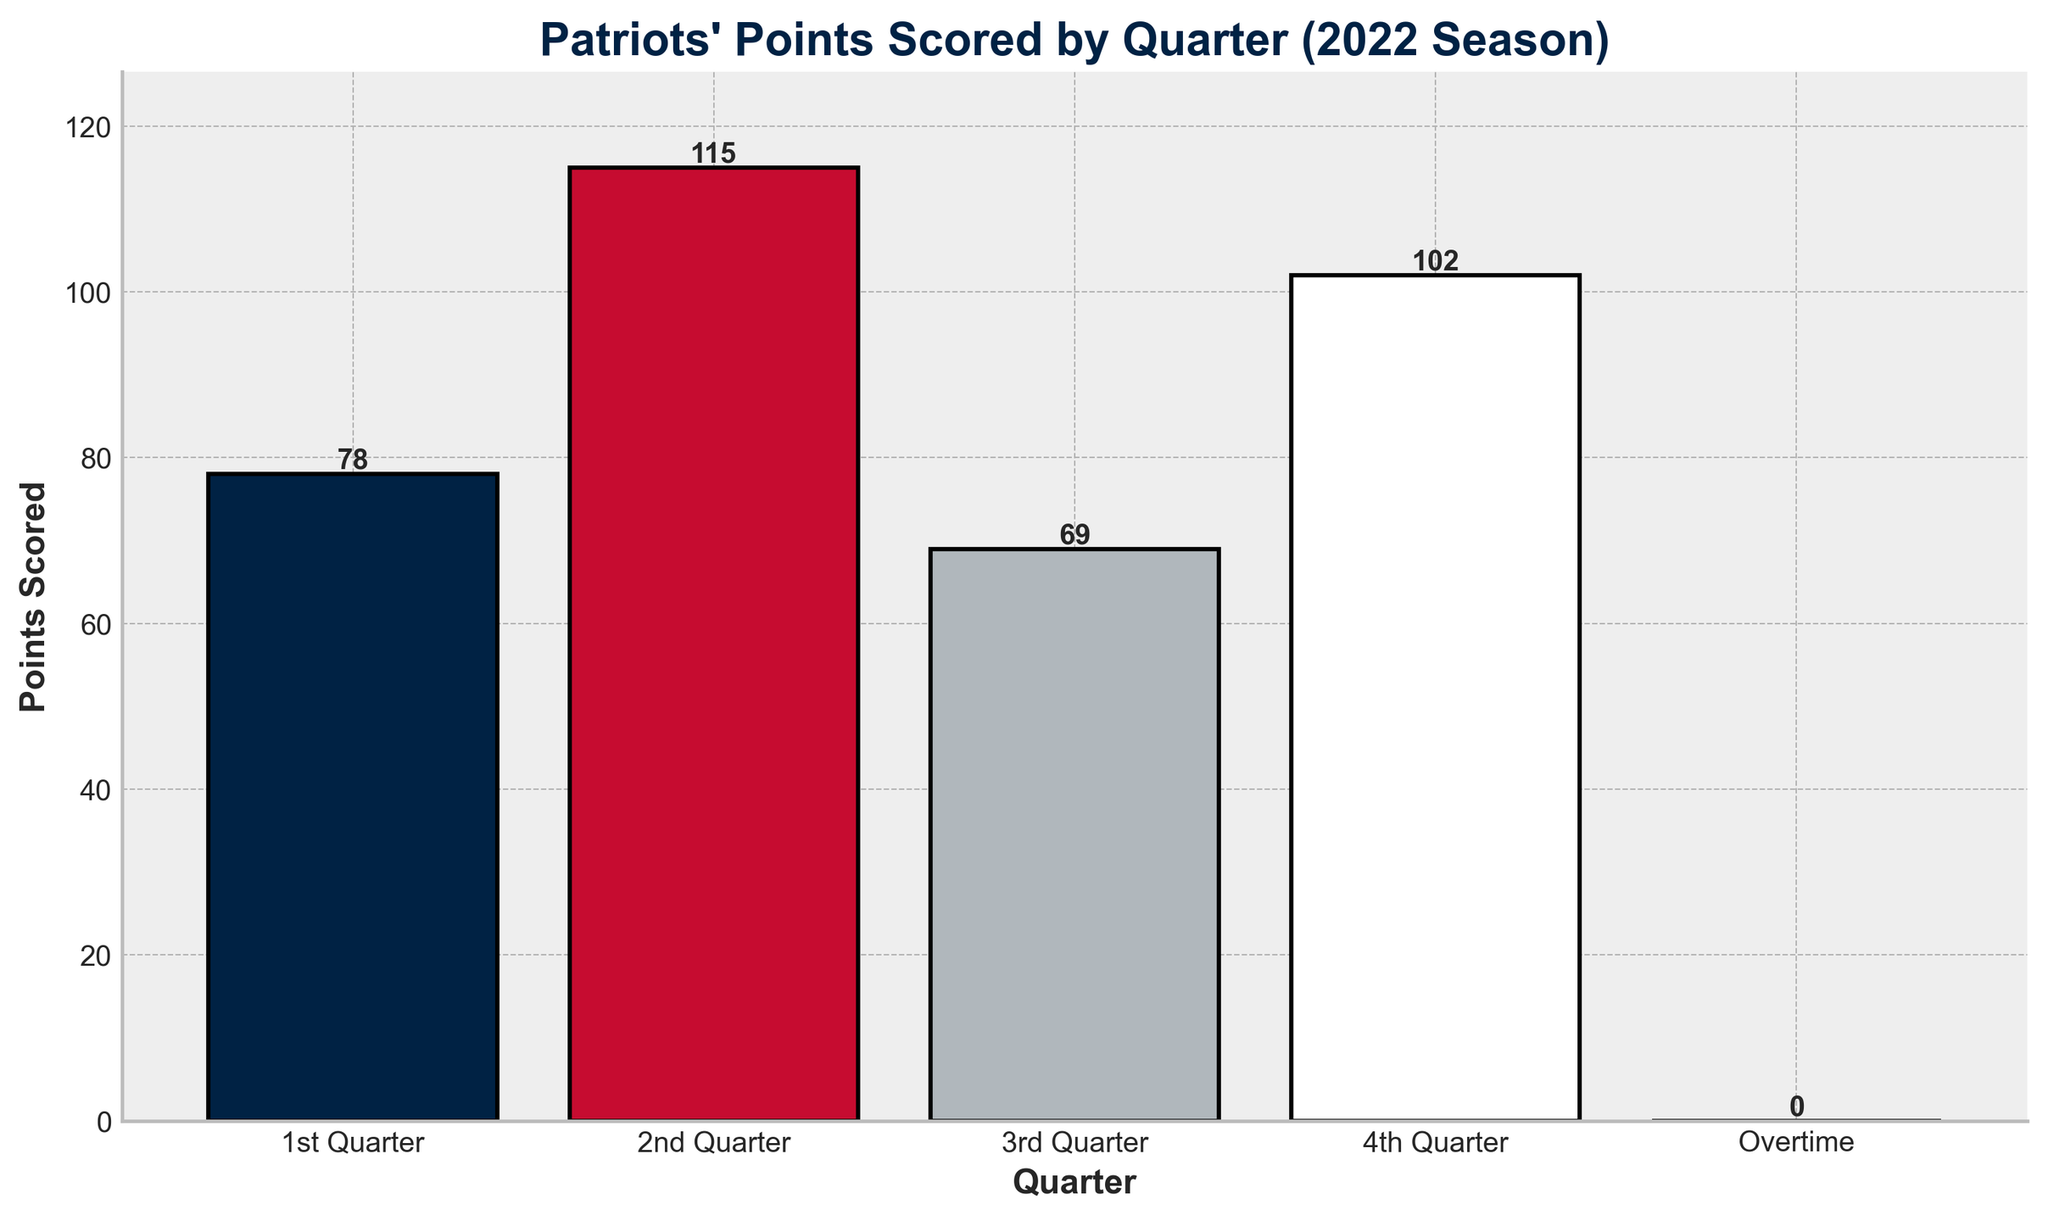What's the total number of points scored in the 1st and 3rd quarters combined? First, find the points scored in the 1st quarter (78) and the 3rd quarter (69). Then, add them together: 78 + 69 = 147.
Answer: 147 Which quarter had the highest points scored? Compare the points scored in each quarter: 1st quarter (78), 2nd quarter (115), 3rd quarter (69), 4th quarter (102), and Overtime (0). The 2nd quarter has the highest points scored at 115.
Answer: 2nd quarter What's the difference in points between the 2nd and 3rd quarters? Find the points scored in the 2nd quarter (115) and the 3rd quarter (69). Subtract the points scored in the 3rd quarter from the points scored in the 2nd quarter: 115 - 69 = 46.
Answer: 46 What is the average number of points scored per quarter (excluding Overtime)? Find the points scored in each quarter: 1st quarter (78), 2nd quarter (115), 3rd quarter (69), and 4th quarter (102). Add them together: 78 + 115 + 69 + 102 = 364. Divide by the number of quarters (4): 364 / 4 = 91.
Answer: 91 Which quarter had the lowest points scored? Compare the points scored in each quarter: 1st quarter (78), 2nd quarter (115), 3rd quarter (69), 4th quarter (102), and Overtime (0). The 3rd quarter has the lowest points scored at 69.
Answer: 3rd quarter How many more points were scored in the 4th quarter compared to the 1st quarter? Find the points scored in the 4th quarter (102) and the 1st quarter (78). Subtract the points scored in the 1st quarter from the points scored in the 4th quarter: 102 - 78 = 24.
Answer: 24 What is the combined total of points scored in the 2nd and 4th quarters? Find the points scored in the 2nd quarter (115) and the 4th quarter (102). Add them together: 115 + 102 = 217.
Answer: 217 Which quarters had more than 100 points scored? Find the points scored in each quarter: 1st quarter (78), 2nd quarter (115), 3rd quarter (69), and 4th quarter (102). The 2nd (115) and 4th (102) quarters had more than 100 points scored.
Answer: 2nd quarter and 4th quarter 